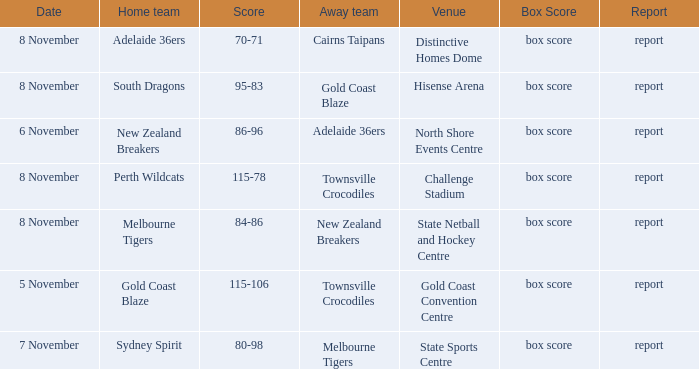What was the box score during a game that had a score of 86-96? Box score. 